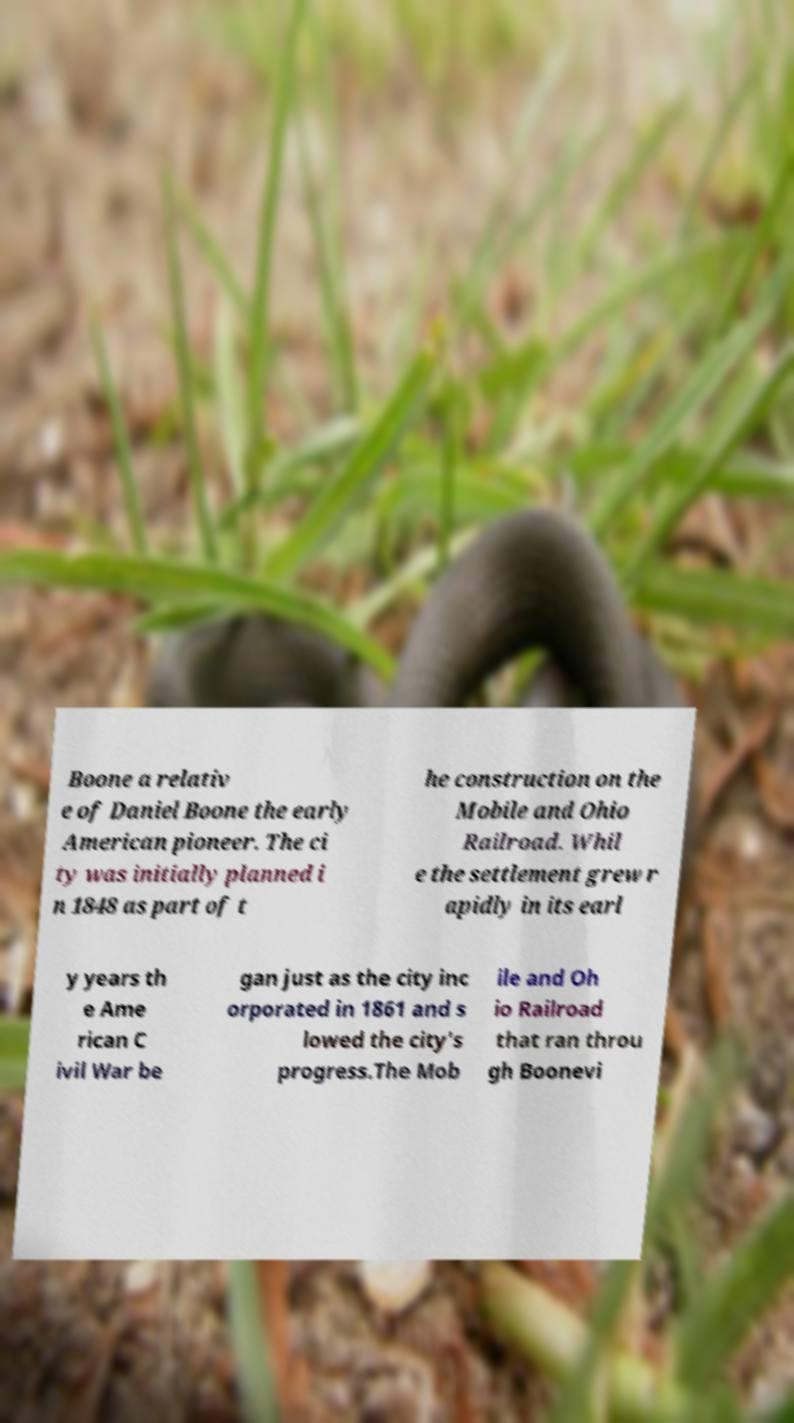Can you accurately transcribe the text from the provided image for me? Boone a relativ e of Daniel Boone the early American pioneer. The ci ty was initially planned i n 1848 as part of t he construction on the Mobile and Ohio Railroad. Whil e the settlement grew r apidly in its earl y years th e Ame rican C ivil War be gan just as the city inc orporated in 1861 and s lowed the city's progress.The Mob ile and Oh io Railroad that ran throu gh Boonevi 